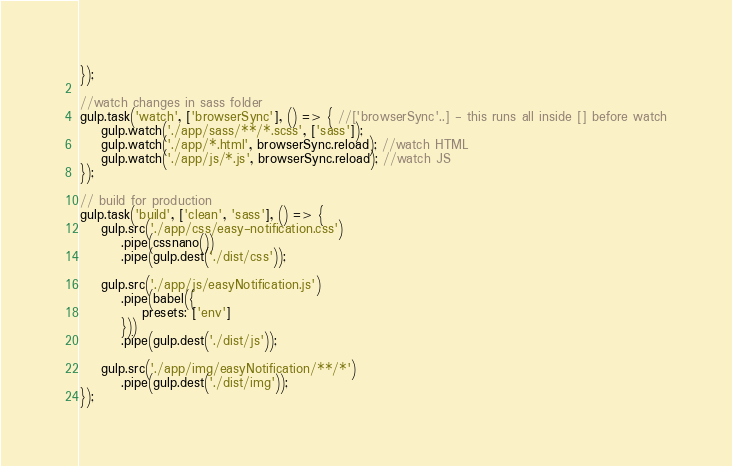Convert code to text. <code><loc_0><loc_0><loc_500><loc_500><_JavaScript_>});

//watch changes in sass folder
gulp.task('watch', ['browserSync'], () => { //['browserSync'..] - this runs all inside [] before watch
    gulp.watch('./app/sass/**/*.scss', ['sass']);
    gulp.watch('./app/*.html', browserSync.reload); //watch HTML
    gulp.watch('./app/js/*.js', browserSync.reload); //watch JS
});

// build for production
gulp.task('build', ['clean', 'sass'], () => {
    gulp.src('./app/css/easy-notification.css')
        .pipe(cssnano())
        .pipe(gulp.dest('./dist/css'));

    gulp.src('./app/js/easyNotification.js')
        .pipe(babel({
            presets: ['env']
        }))
        .pipe(gulp.dest('./dist/js'));

    gulp.src('./app/img/easyNotification/**/*')
        .pipe(gulp.dest('./dist/img'));
});
</code> 